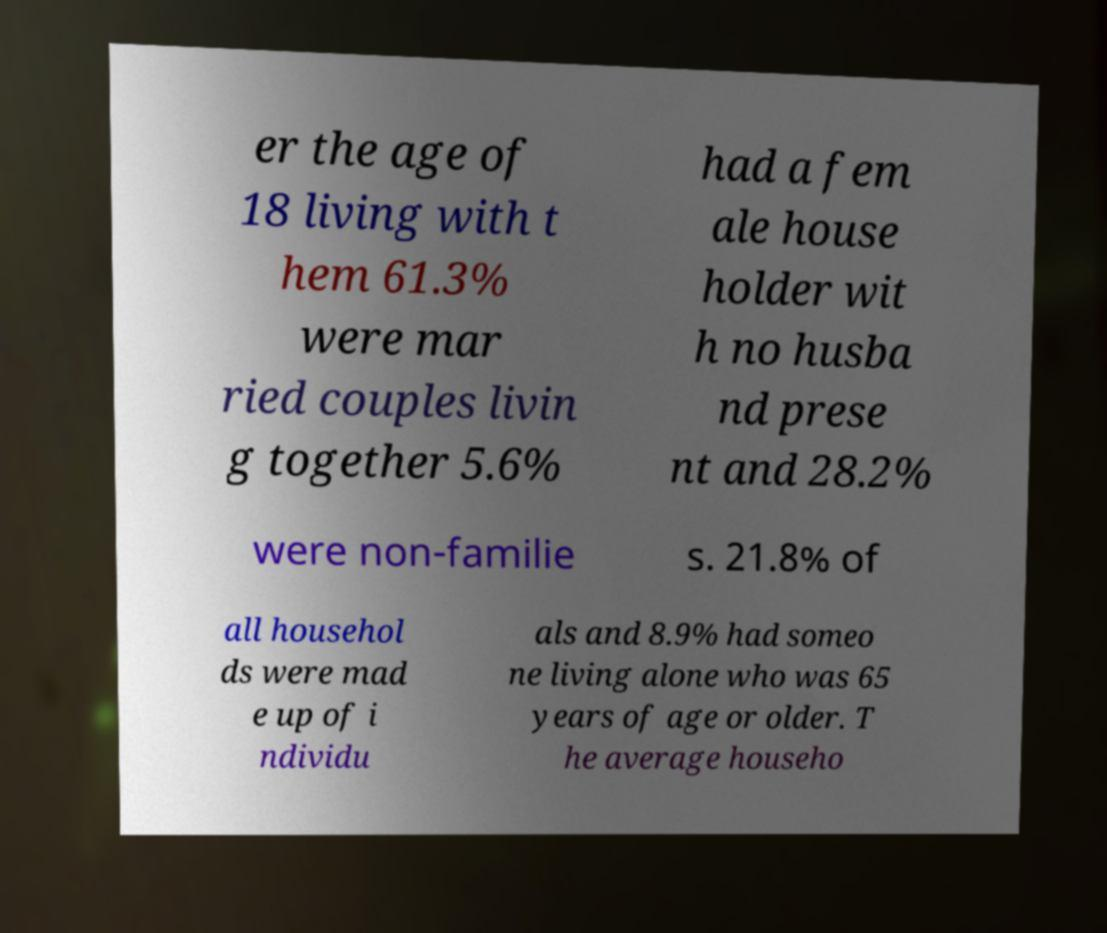I need the written content from this picture converted into text. Can you do that? er the age of 18 living with t hem 61.3% were mar ried couples livin g together 5.6% had a fem ale house holder wit h no husba nd prese nt and 28.2% were non-familie s. 21.8% of all househol ds were mad e up of i ndividu als and 8.9% had someo ne living alone who was 65 years of age or older. T he average househo 